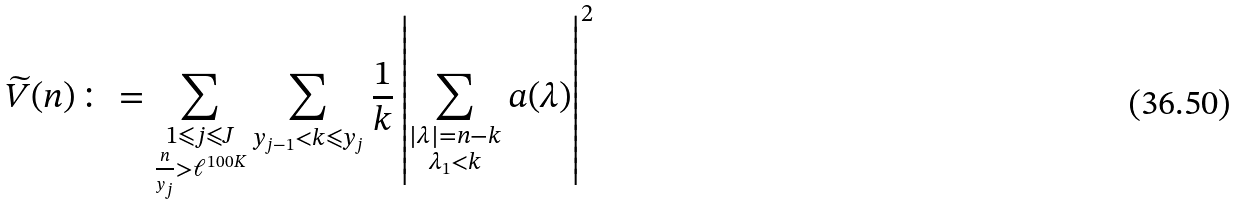<formula> <loc_0><loc_0><loc_500><loc_500>\widetilde { V } ( n ) \colon = \sum _ { \substack { 1 \leqslant j \leqslant J \\ \frac { n } { y _ { j } } > \ell ^ { 1 0 0 K } } } \sum _ { y _ { j - 1 } < k \leqslant y _ { j } } \frac { 1 } { k } \left | \sum _ { \substack { | \lambda | = n - k \\ \lambda _ { 1 } < k } } a ( \lambda ) \right | ^ { 2 }</formula> 